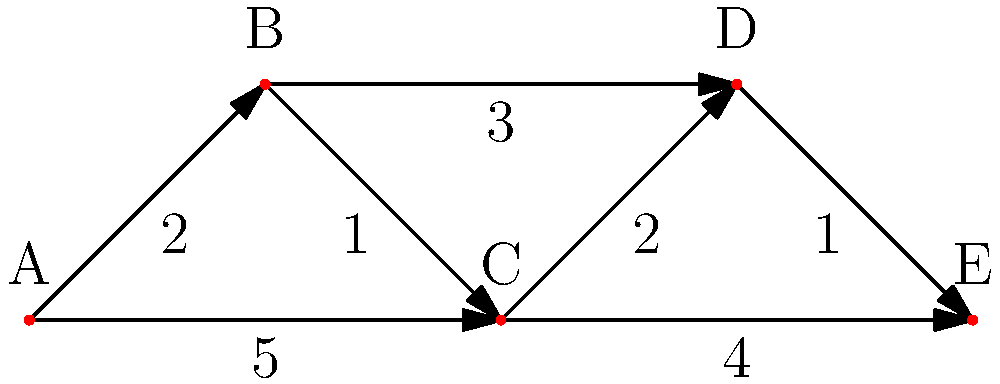As a music producer focusing on political themes, you want to spread a new message through a network of collaborating artists. The graph represents the network, where nodes are artists and edge weights are the time (in weeks) it takes for a message to spread between them. If you start spreading your message from artist A, what's the minimum time needed for the message to reach artist E? To solve this problem, we'll use Dijkstra's algorithm to find the shortest path from A to E:

1. Initialize:
   - Distance to A: 0
   - Distance to all other nodes: ∞
   - Set of unvisited nodes: {A, B, C, D, E}

2. From A:
   - Update B: min(∞, 0 + 2) = 2
   - Update C: min(∞, 0 + 5) = 5
   - Mark A as visited

3. Choose B (smallest distance):
   - Update C: min(5, 2 + 1) = 3
   - Update D: min(∞, 2 + 3) = 5
   - Mark B as visited

4. Choose C:
   - Update D: min(5, 3 + 2) = 5
   - Update E: min(∞, 3 + 4) = 7
   - Mark C as visited

5. Choose D:
   - Update E: min(7, 5 + 1) = 6
   - Mark D as visited

6. E is the only remaining node, so we're done.

The shortest path from A to E is A → B → C → D → E, with a total time of 6 weeks.
Answer: 6 weeks 